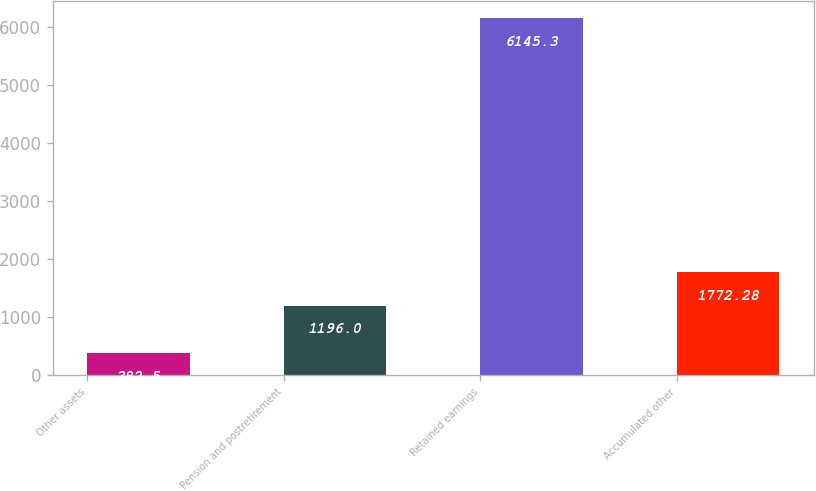Convert chart to OTSL. <chart><loc_0><loc_0><loc_500><loc_500><bar_chart><fcel>Other assets<fcel>Pension and postretirement<fcel>Retained earnings<fcel>Accumulated other<nl><fcel>382.5<fcel>1196<fcel>6145.3<fcel>1772.28<nl></chart> 